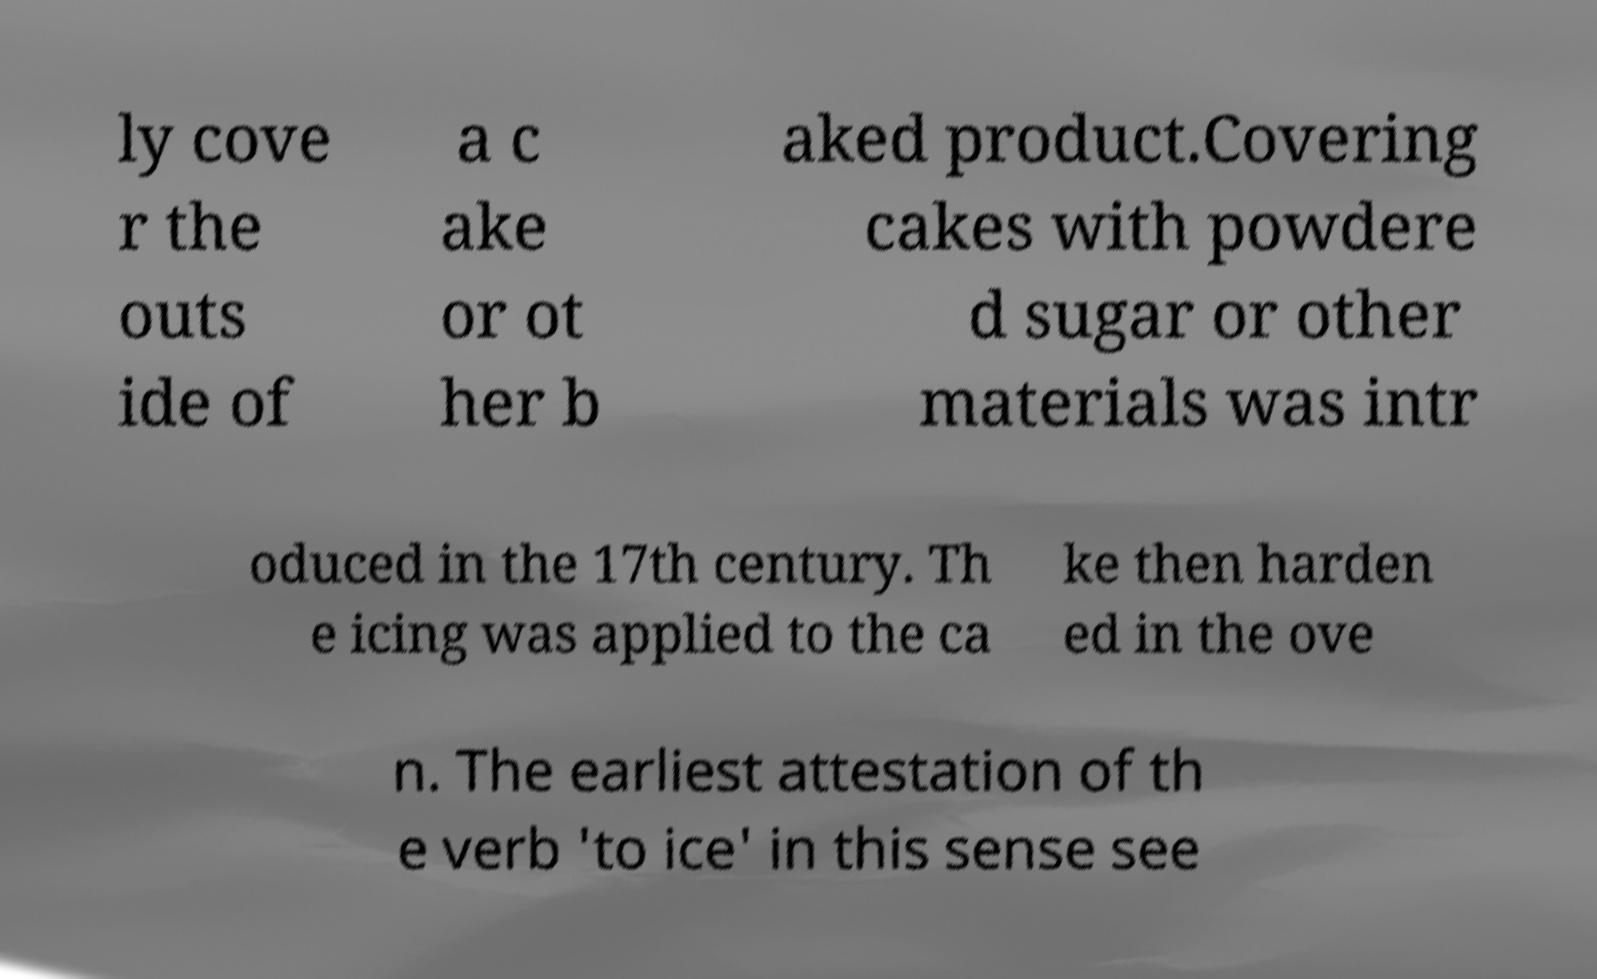Please identify and transcribe the text found in this image. ly cove r the outs ide of a c ake or ot her b aked product.Covering cakes with powdere d sugar or other materials was intr oduced in the 17th century. Th e icing was applied to the ca ke then harden ed in the ove n. The earliest attestation of th e verb 'to ice' in this sense see 